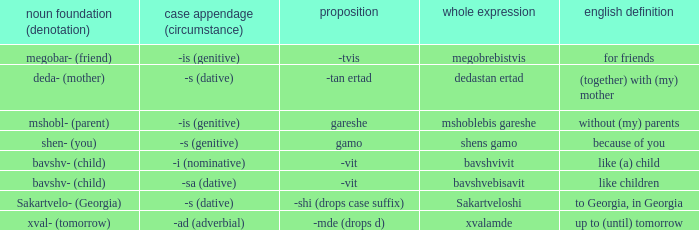What is Postposition, when Noun Root (Meaning) is "mshobl- (parent)"? Gareshe. 